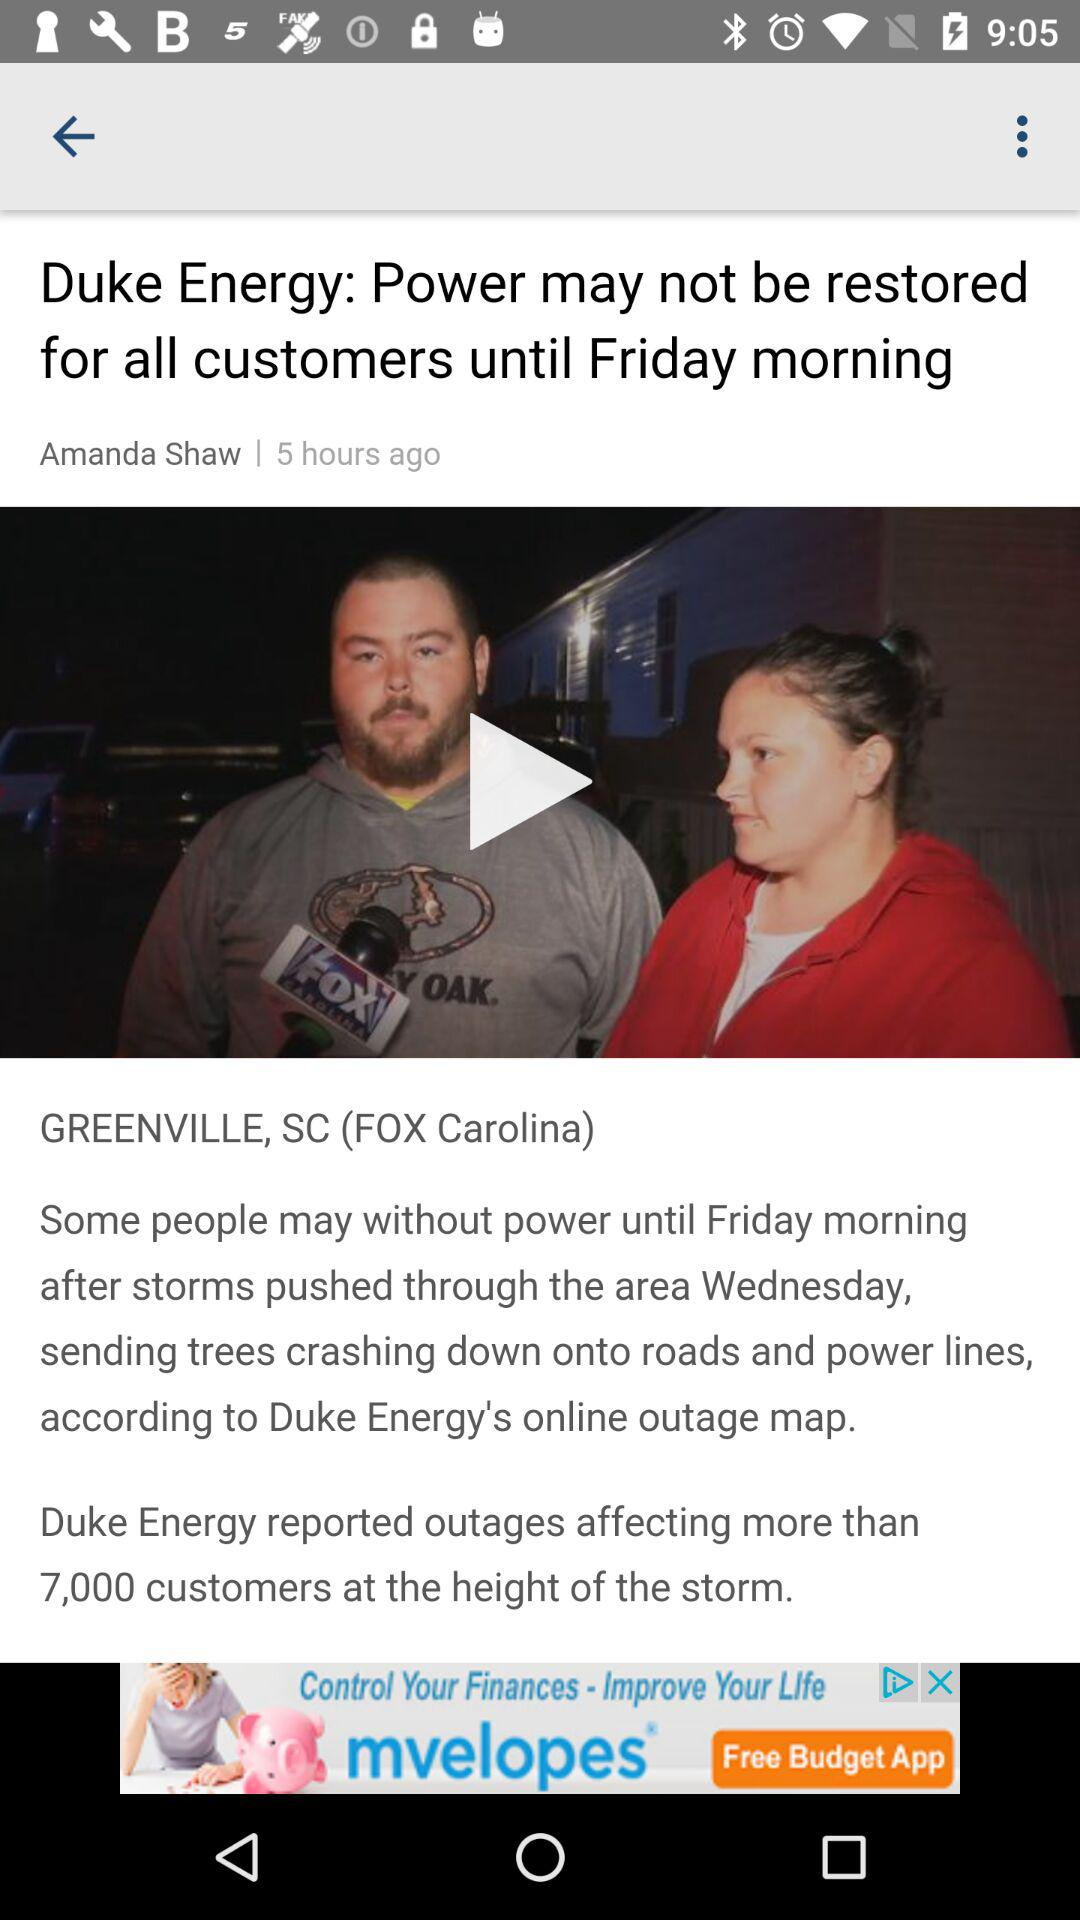How many hours ago was this article published?
Answer the question using a single word or phrase. 5 